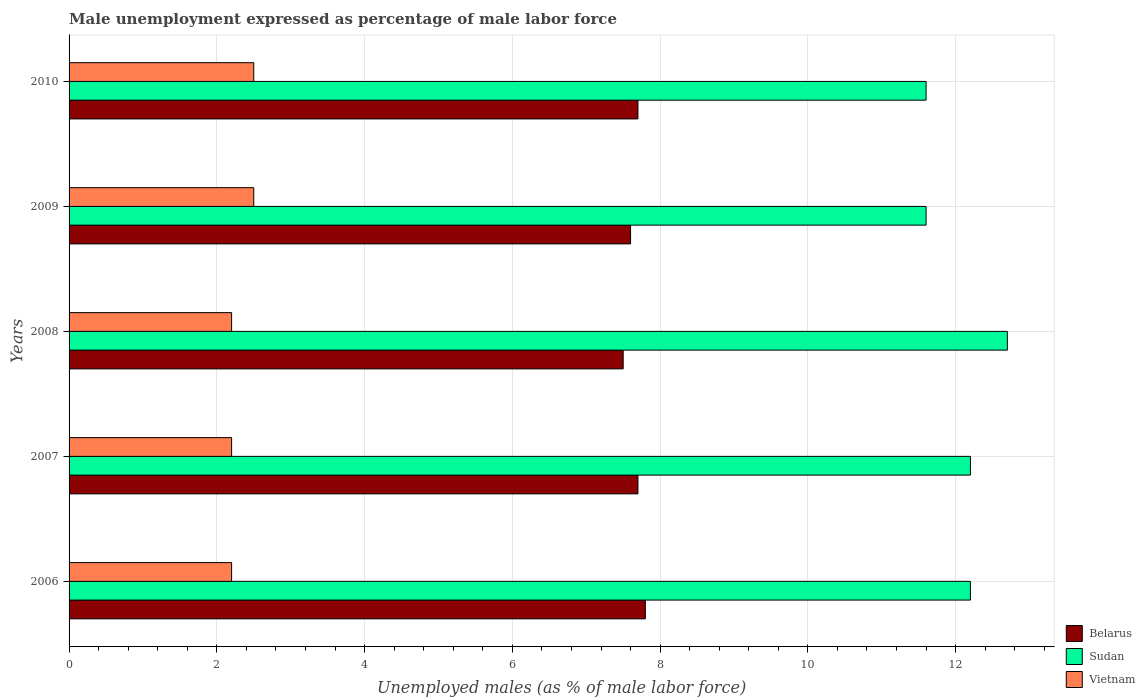How many groups of bars are there?
Ensure brevity in your answer.  5. Are the number of bars per tick equal to the number of legend labels?
Keep it short and to the point. Yes. Are the number of bars on each tick of the Y-axis equal?
Offer a very short reply. Yes. How many bars are there on the 3rd tick from the bottom?
Provide a short and direct response. 3. What is the label of the 1st group of bars from the top?
Your answer should be compact. 2010. What is the unemployment in males in in Vietnam in 2010?
Ensure brevity in your answer.  2.5. Across all years, what is the maximum unemployment in males in in Sudan?
Ensure brevity in your answer.  12.7. Across all years, what is the minimum unemployment in males in in Sudan?
Provide a short and direct response. 11.6. In which year was the unemployment in males in in Vietnam minimum?
Make the answer very short. 2006. What is the total unemployment in males in in Vietnam in the graph?
Your response must be concise. 11.6. What is the difference between the unemployment in males in in Vietnam in 2007 and that in 2010?
Provide a short and direct response. -0.3. What is the difference between the unemployment in males in in Belarus in 2010 and the unemployment in males in in Vietnam in 2009?
Your response must be concise. 5.2. What is the average unemployment in males in in Vietnam per year?
Provide a short and direct response. 2.32. In the year 2008, what is the difference between the unemployment in males in in Sudan and unemployment in males in in Vietnam?
Your answer should be compact. 10.5. Is the difference between the unemployment in males in in Sudan in 2006 and 2008 greater than the difference between the unemployment in males in in Vietnam in 2006 and 2008?
Provide a succinct answer. No. What is the difference between the highest and the second highest unemployment in males in in Vietnam?
Offer a terse response. 0. What is the difference between the highest and the lowest unemployment in males in in Belarus?
Keep it short and to the point. 0.3. In how many years, is the unemployment in males in in Belarus greater than the average unemployment in males in in Belarus taken over all years?
Your response must be concise. 3. Is the sum of the unemployment in males in in Vietnam in 2008 and 2009 greater than the maximum unemployment in males in in Belarus across all years?
Your answer should be very brief. No. What does the 1st bar from the top in 2008 represents?
Give a very brief answer. Vietnam. What does the 3rd bar from the bottom in 2010 represents?
Offer a very short reply. Vietnam. Is it the case that in every year, the sum of the unemployment in males in in Vietnam and unemployment in males in in Belarus is greater than the unemployment in males in in Sudan?
Provide a succinct answer. No. Are all the bars in the graph horizontal?
Provide a short and direct response. Yes. How many years are there in the graph?
Offer a very short reply. 5. Are the values on the major ticks of X-axis written in scientific E-notation?
Keep it short and to the point. No. Does the graph contain any zero values?
Provide a succinct answer. No. Where does the legend appear in the graph?
Offer a very short reply. Bottom right. How are the legend labels stacked?
Make the answer very short. Vertical. What is the title of the graph?
Provide a short and direct response. Male unemployment expressed as percentage of male labor force. What is the label or title of the X-axis?
Keep it short and to the point. Unemployed males (as % of male labor force). What is the Unemployed males (as % of male labor force) of Belarus in 2006?
Provide a succinct answer. 7.8. What is the Unemployed males (as % of male labor force) in Sudan in 2006?
Your answer should be compact. 12.2. What is the Unemployed males (as % of male labor force) in Vietnam in 2006?
Provide a succinct answer. 2.2. What is the Unemployed males (as % of male labor force) in Belarus in 2007?
Your response must be concise. 7.7. What is the Unemployed males (as % of male labor force) in Sudan in 2007?
Make the answer very short. 12.2. What is the Unemployed males (as % of male labor force) of Vietnam in 2007?
Give a very brief answer. 2.2. What is the Unemployed males (as % of male labor force) in Sudan in 2008?
Provide a succinct answer. 12.7. What is the Unemployed males (as % of male labor force) of Vietnam in 2008?
Provide a short and direct response. 2.2. What is the Unemployed males (as % of male labor force) in Belarus in 2009?
Provide a short and direct response. 7.6. What is the Unemployed males (as % of male labor force) in Sudan in 2009?
Offer a very short reply. 11.6. What is the Unemployed males (as % of male labor force) in Vietnam in 2009?
Offer a terse response. 2.5. What is the Unemployed males (as % of male labor force) in Belarus in 2010?
Provide a succinct answer. 7.7. What is the Unemployed males (as % of male labor force) in Sudan in 2010?
Give a very brief answer. 11.6. Across all years, what is the maximum Unemployed males (as % of male labor force) of Belarus?
Give a very brief answer. 7.8. Across all years, what is the maximum Unemployed males (as % of male labor force) of Sudan?
Offer a terse response. 12.7. Across all years, what is the minimum Unemployed males (as % of male labor force) in Belarus?
Your answer should be compact. 7.5. Across all years, what is the minimum Unemployed males (as % of male labor force) in Sudan?
Offer a very short reply. 11.6. Across all years, what is the minimum Unemployed males (as % of male labor force) of Vietnam?
Your answer should be very brief. 2.2. What is the total Unemployed males (as % of male labor force) of Belarus in the graph?
Give a very brief answer. 38.3. What is the total Unemployed males (as % of male labor force) of Sudan in the graph?
Offer a very short reply. 60.3. What is the difference between the Unemployed males (as % of male labor force) of Vietnam in 2006 and that in 2007?
Offer a terse response. 0. What is the difference between the Unemployed males (as % of male labor force) in Belarus in 2006 and that in 2008?
Make the answer very short. 0.3. What is the difference between the Unemployed males (as % of male labor force) of Sudan in 2006 and that in 2008?
Ensure brevity in your answer.  -0.5. What is the difference between the Unemployed males (as % of male labor force) in Vietnam in 2006 and that in 2008?
Your response must be concise. 0. What is the difference between the Unemployed males (as % of male labor force) of Vietnam in 2006 and that in 2009?
Give a very brief answer. -0.3. What is the difference between the Unemployed males (as % of male labor force) in Belarus in 2006 and that in 2010?
Provide a succinct answer. 0.1. What is the difference between the Unemployed males (as % of male labor force) in Sudan in 2006 and that in 2010?
Keep it short and to the point. 0.6. What is the difference between the Unemployed males (as % of male labor force) of Belarus in 2007 and that in 2008?
Ensure brevity in your answer.  0.2. What is the difference between the Unemployed males (as % of male labor force) in Vietnam in 2007 and that in 2009?
Provide a succinct answer. -0.3. What is the difference between the Unemployed males (as % of male labor force) in Belarus in 2007 and that in 2010?
Provide a succinct answer. 0. What is the difference between the Unemployed males (as % of male labor force) of Sudan in 2007 and that in 2010?
Provide a succinct answer. 0.6. What is the difference between the Unemployed males (as % of male labor force) of Belarus in 2008 and that in 2009?
Your answer should be compact. -0.1. What is the difference between the Unemployed males (as % of male labor force) in Vietnam in 2008 and that in 2009?
Keep it short and to the point. -0.3. What is the difference between the Unemployed males (as % of male labor force) of Sudan in 2009 and that in 2010?
Provide a succinct answer. 0. What is the difference between the Unemployed males (as % of male labor force) in Belarus in 2006 and the Unemployed males (as % of male labor force) in Sudan in 2007?
Make the answer very short. -4.4. What is the difference between the Unemployed males (as % of male labor force) of Sudan in 2006 and the Unemployed males (as % of male labor force) of Vietnam in 2009?
Provide a succinct answer. 9.7. What is the difference between the Unemployed males (as % of male labor force) in Belarus in 2006 and the Unemployed males (as % of male labor force) in Sudan in 2010?
Ensure brevity in your answer.  -3.8. What is the difference between the Unemployed males (as % of male labor force) of Sudan in 2006 and the Unemployed males (as % of male labor force) of Vietnam in 2010?
Your answer should be very brief. 9.7. What is the difference between the Unemployed males (as % of male labor force) in Belarus in 2007 and the Unemployed males (as % of male labor force) in Sudan in 2008?
Give a very brief answer. -5. What is the difference between the Unemployed males (as % of male labor force) in Belarus in 2007 and the Unemployed males (as % of male labor force) in Vietnam in 2008?
Your response must be concise. 5.5. What is the difference between the Unemployed males (as % of male labor force) of Belarus in 2007 and the Unemployed males (as % of male labor force) of Vietnam in 2009?
Your answer should be very brief. 5.2. What is the difference between the Unemployed males (as % of male labor force) in Sudan in 2007 and the Unemployed males (as % of male labor force) in Vietnam in 2009?
Make the answer very short. 9.7. What is the difference between the Unemployed males (as % of male labor force) in Belarus in 2007 and the Unemployed males (as % of male labor force) in Sudan in 2010?
Ensure brevity in your answer.  -3.9. What is the difference between the Unemployed males (as % of male labor force) in Belarus in 2007 and the Unemployed males (as % of male labor force) in Vietnam in 2010?
Provide a succinct answer. 5.2. What is the difference between the Unemployed males (as % of male labor force) in Belarus in 2008 and the Unemployed males (as % of male labor force) in Sudan in 2009?
Make the answer very short. -4.1. What is the difference between the Unemployed males (as % of male labor force) in Belarus in 2008 and the Unemployed males (as % of male labor force) in Vietnam in 2009?
Keep it short and to the point. 5. What is the difference between the Unemployed males (as % of male labor force) of Sudan in 2008 and the Unemployed males (as % of male labor force) of Vietnam in 2009?
Provide a succinct answer. 10.2. What is the difference between the Unemployed males (as % of male labor force) of Belarus in 2008 and the Unemployed males (as % of male labor force) of Sudan in 2010?
Ensure brevity in your answer.  -4.1. What is the difference between the Unemployed males (as % of male labor force) in Belarus in 2009 and the Unemployed males (as % of male labor force) in Vietnam in 2010?
Keep it short and to the point. 5.1. What is the average Unemployed males (as % of male labor force) of Belarus per year?
Offer a very short reply. 7.66. What is the average Unemployed males (as % of male labor force) in Sudan per year?
Make the answer very short. 12.06. What is the average Unemployed males (as % of male labor force) of Vietnam per year?
Provide a short and direct response. 2.32. In the year 2006, what is the difference between the Unemployed males (as % of male labor force) in Belarus and Unemployed males (as % of male labor force) in Vietnam?
Your answer should be very brief. 5.6. In the year 2006, what is the difference between the Unemployed males (as % of male labor force) of Sudan and Unemployed males (as % of male labor force) of Vietnam?
Your answer should be compact. 10. In the year 2009, what is the difference between the Unemployed males (as % of male labor force) in Belarus and Unemployed males (as % of male labor force) in Sudan?
Make the answer very short. -4. In the year 2010, what is the difference between the Unemployed males (as % of male labor force) in Belarus and Unemployed males (as % of male labor force) in Sudan?
Ensure brevity in your answer.  -3.9. In the year 2010, what is the difference between the Unemployed males (as % of male labor force) of Sudan and Unemployed males (as % of male labor force) of Vietnam?
Make the answer very short. 9.1. What is the ratio of the Unemployed males (as % of male labor force) in Belarus in 2006 to that in 2007?
Keep it short and to the point. 1.01. What is the ratio of the Unemployed males (as % of male labor force) of Sudan in 2006 to that in 2008?
Offer a very short reply. 0.96. What is the ratio of the Unemployed males (as % of male labor force) of Belarus in 2006 to that in 2009?
Offer a very short reply. 1.03. What is the ratio of the Unemployed males (as % of male labor force) of Sudan in 2006 to that in 2009?
Provide a succinct answer. 1.05. What is the ratio of the Unemployed males (as % of male labor force) of Sudan in 2006 to that in 2010?
Offer a very short reply. 1.05. What is the ratio of the Unemployed males (as % of male labor force) of Vietnam in 2006 to that in 2010?
Provide a succinct answer. 0.88. What is the ratio of the Unemployed males (as % of male labor force) in Belarus in 2007 to that in 2008?
Offer a very short reply. 1.03. What is the ratio of the Unemployed males (as % of male labor force) of Sudan in 2007 to that in 2008?
Give a very brief answer. 0.96. What is the ratio of the Unemployed males (as % of male labor force) in Vietnam in 2007 to that in 2008?
Give a very brief answer. 1. What is the ratio of the Unemployed males (as % of male labor force) in Belarus in 2007 to that in 2009?
Provide a succinct answer. 1.01. What is the ratio of the Unemployed males (as % of male labor force) of Sudan in 2007 to that in 2009?
Your answer should be very brief. 1.05. What is the ratio of the Unemployed males (as % of male labor force) in Vietnam in 2007 to that in 2009?
Provide a succinct answer. 0.88. What is the ratio of the Unemployed males (as % of male labor force) in Sudan in 2007 to that in 2010?
Your answer should be compact. 1.05. What is the ratio of the Unemployed males (as % of male labor force) of Vietnam in 2007 to that in 2010?
Your answer should be very brief. 0.88. What is the ratio of the Unemployed males (as % of male labor force) of Sudan in 2008 to that in 2009?
Provide a succinct answer. 1.09. What is the ratio of the Unemployed males (as % of male labor force) in Sudan in 2008 to that in 2010?
Provide a short and direct response. 1.09. What is the ratio of the Unemployed males (as % of male labor force) in Vietnam in 2009 to that in 2010?
Make the answer very short. 1. What is the difference between the highest and the lowest Unemployed males (as % of male labor force) of Belarus?
Your response must be concise. 0.3. What is the difference between the highest and the lowest Unemployed males (as % of male labor force) of Sudan?
Provide a succinct answer. 1.1. 